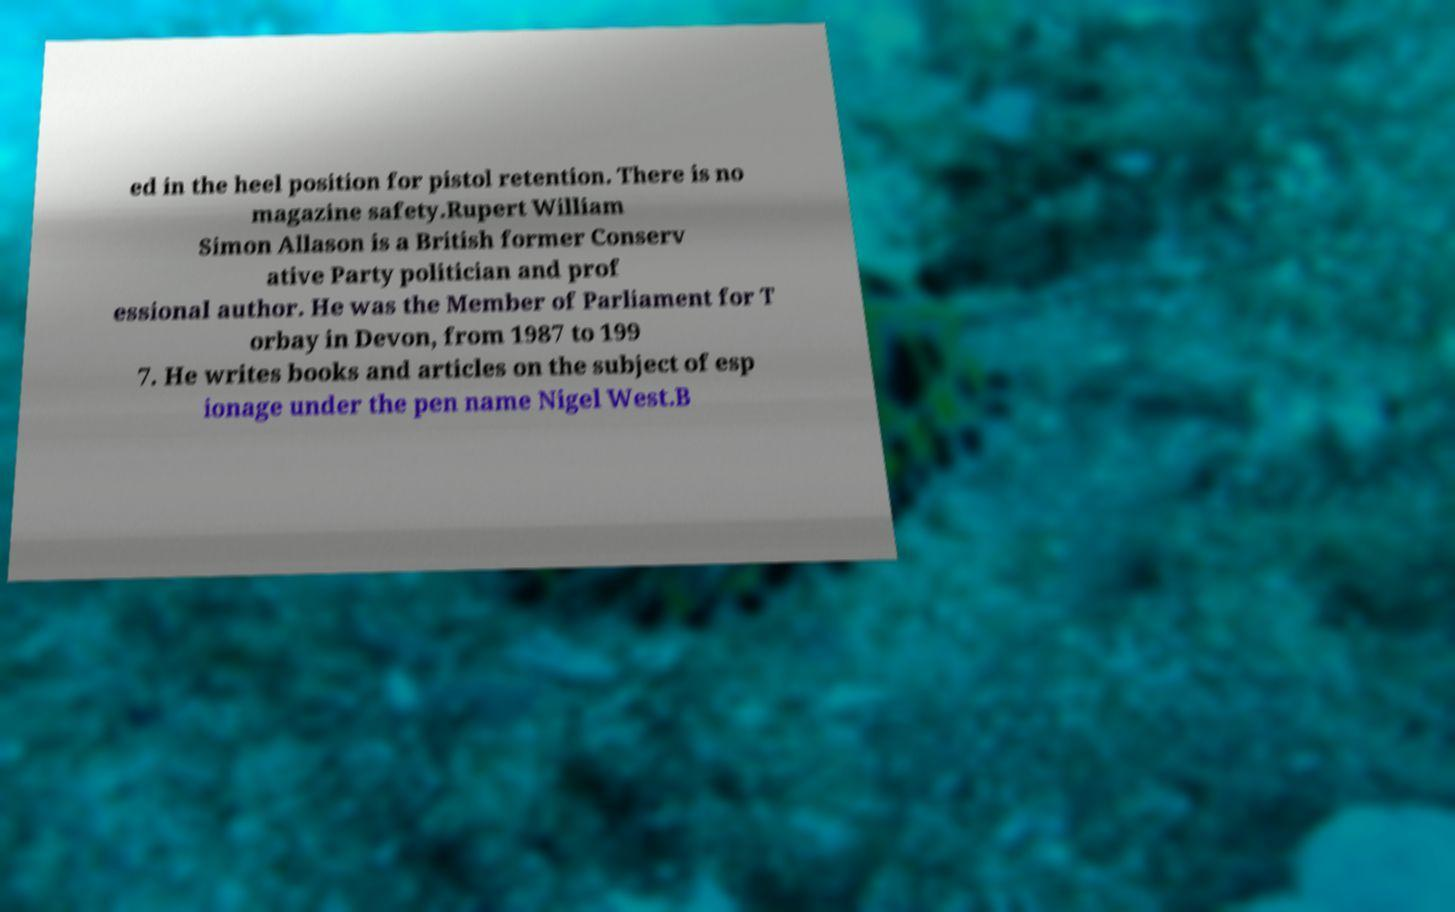Could you assist in decoding the text presented in this image and type it out clearly? ed in the heel position for pistol retention. There is no magazine safety.Rupert William Simon Allason is a British former Conserv ative Party politician and prof essional author. He was the Member of Parliament for T orbay in Devon, from 1987 to 199 7. He writes books and articles on the subject of esp ionage under the pen name Nigel West.B 